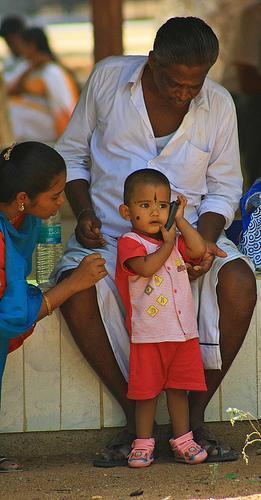How many water bottles?
Give a very brief answer. 1. 